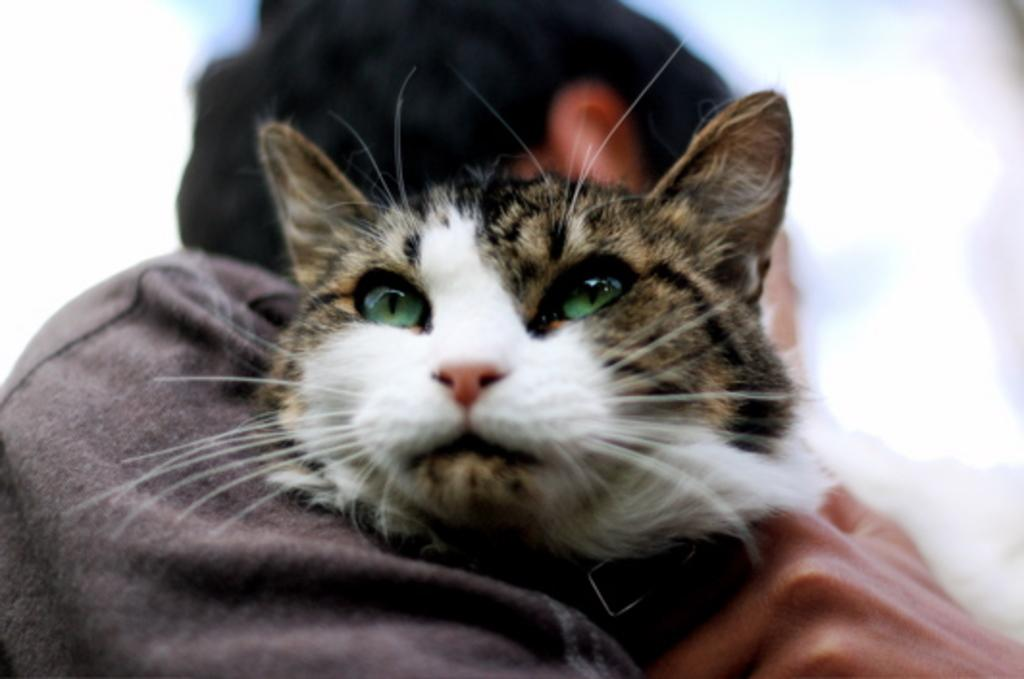Who or what is the main subject in the image? There is a person in the image. What is the person holding in the image? The person is holding a cat. What is the color of the background in the image? The background in the image is white. What type of magic is the person performing with the pickle in the image? There is no pickle present in the image, and therefore no magic can be observed. 